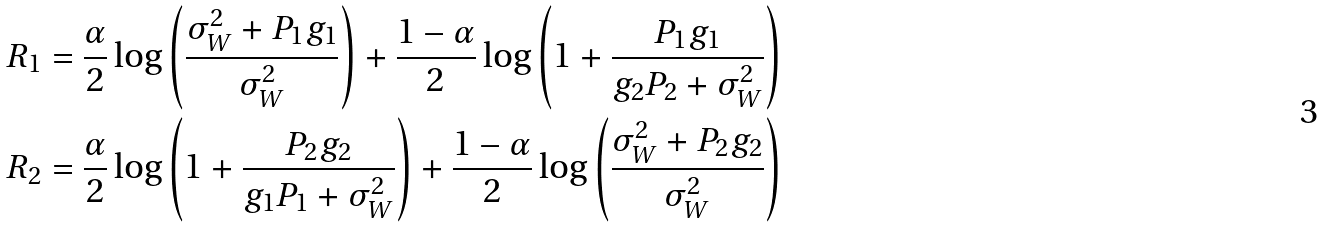<formula> <loc_0><loc_0><loc_500><loc_500>R _ { 1 } = \frac { \alpha } { 2 } \log \left ( \frac { \sigma _ { W } ^ { 2 } + P _ { 1 } g _ { 1 } } { \sigma _ { W } ^ { 2 } } \right ) + \frac { 1 - \alpha } { 2 } \log \left ( 1 + \frac { P _ { 1 } g _ { 1 } } { g _ { 2 } P _ { 2 } + \sigma _ { W } ^ { 2 } } \right ) \\ R _ { 2 } = \frac { \alpha } { 2 } \log \left ( 1 + \frac { P _ { 2 } g _ { 2 } } { g _ { 1 } P _ { 1 } + \sigma _ { W } ^ { 2 } } \right ) + \frac { 1 - \alpha } { 2 } \log \left ( \frac { \sigma _ { W } ^ { 2 } + P _ { 2 } g _ { 2 } } { \sigma _ { W } ^ { 2 } } \right )</formula> 